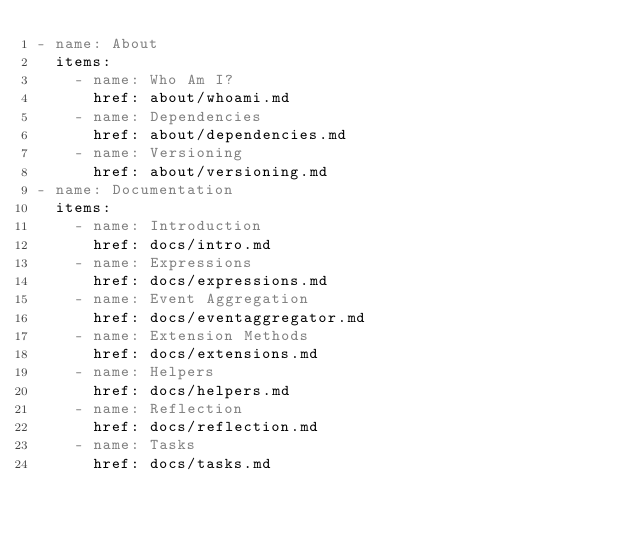Convert code to text. <code><loc_0><loc_0><loc_500><loc_500><_YAML_>- name: About
  items:
    - name: Who Am I?
      href: about/whoami.md
    - name: Dependencies
      href: about/dependencies.md
    - name: Versioning
      href: about/versioning.md
- name: Documentation
  items:
    - name: Introduction
      href: docs/intro.md
    - name: Expressions
      href: docs/expressions.md
    - name: Event Aggregation
      href: docs/eventaggregator.md
    - name: Extension Methods
      href: docs/extensions.md
    - name: Helpers
      href: docs/helpers.md
    - name: Reflection
      href: docs/reflection.md
    - name: Tasks
      href: docs/tasks.md</code> 